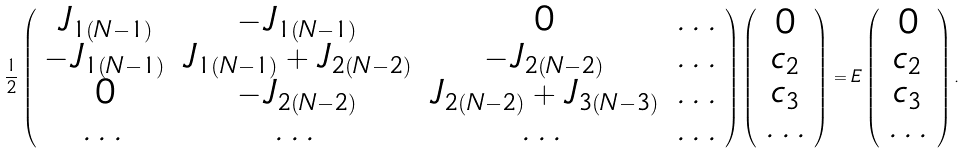Convert formula to latex. <formula><loc_0><loc_0><loc_500><loc_500>\frac { 1 } { 2 } \left ( \begin{array} { c c c c } J _ { 1 ( N - 1 ) } & - J _ { 1 ( N - 1 ) } & 0 & \dots \\ - J _ { 1 ( N - 1 ) } & J _ { 1 ( N - 1 ) } + J _ { 2 ( N - 2 ) } & - J _ { 2 ( N - 2 ) } & \dots \\ 0 & - J _ { 2 ( N - 2 ) } & J _ { 2 ( N - 2 ) } + J _ { 3 ( N - 3 ) } & \dots \\ \dots & \dots & \dots & \dots \end{array} \right ) \left ( \begin{array} { c } 0 \\ c _ { 2 } \\ c _ { 3 } \\ \dots \end{array} \right ) = E \left ( \begin{array} { c } 0 \\ c _ { 2 } \\ c _ { 3 } \\ \dots \end{array} \right ) .</formula> 